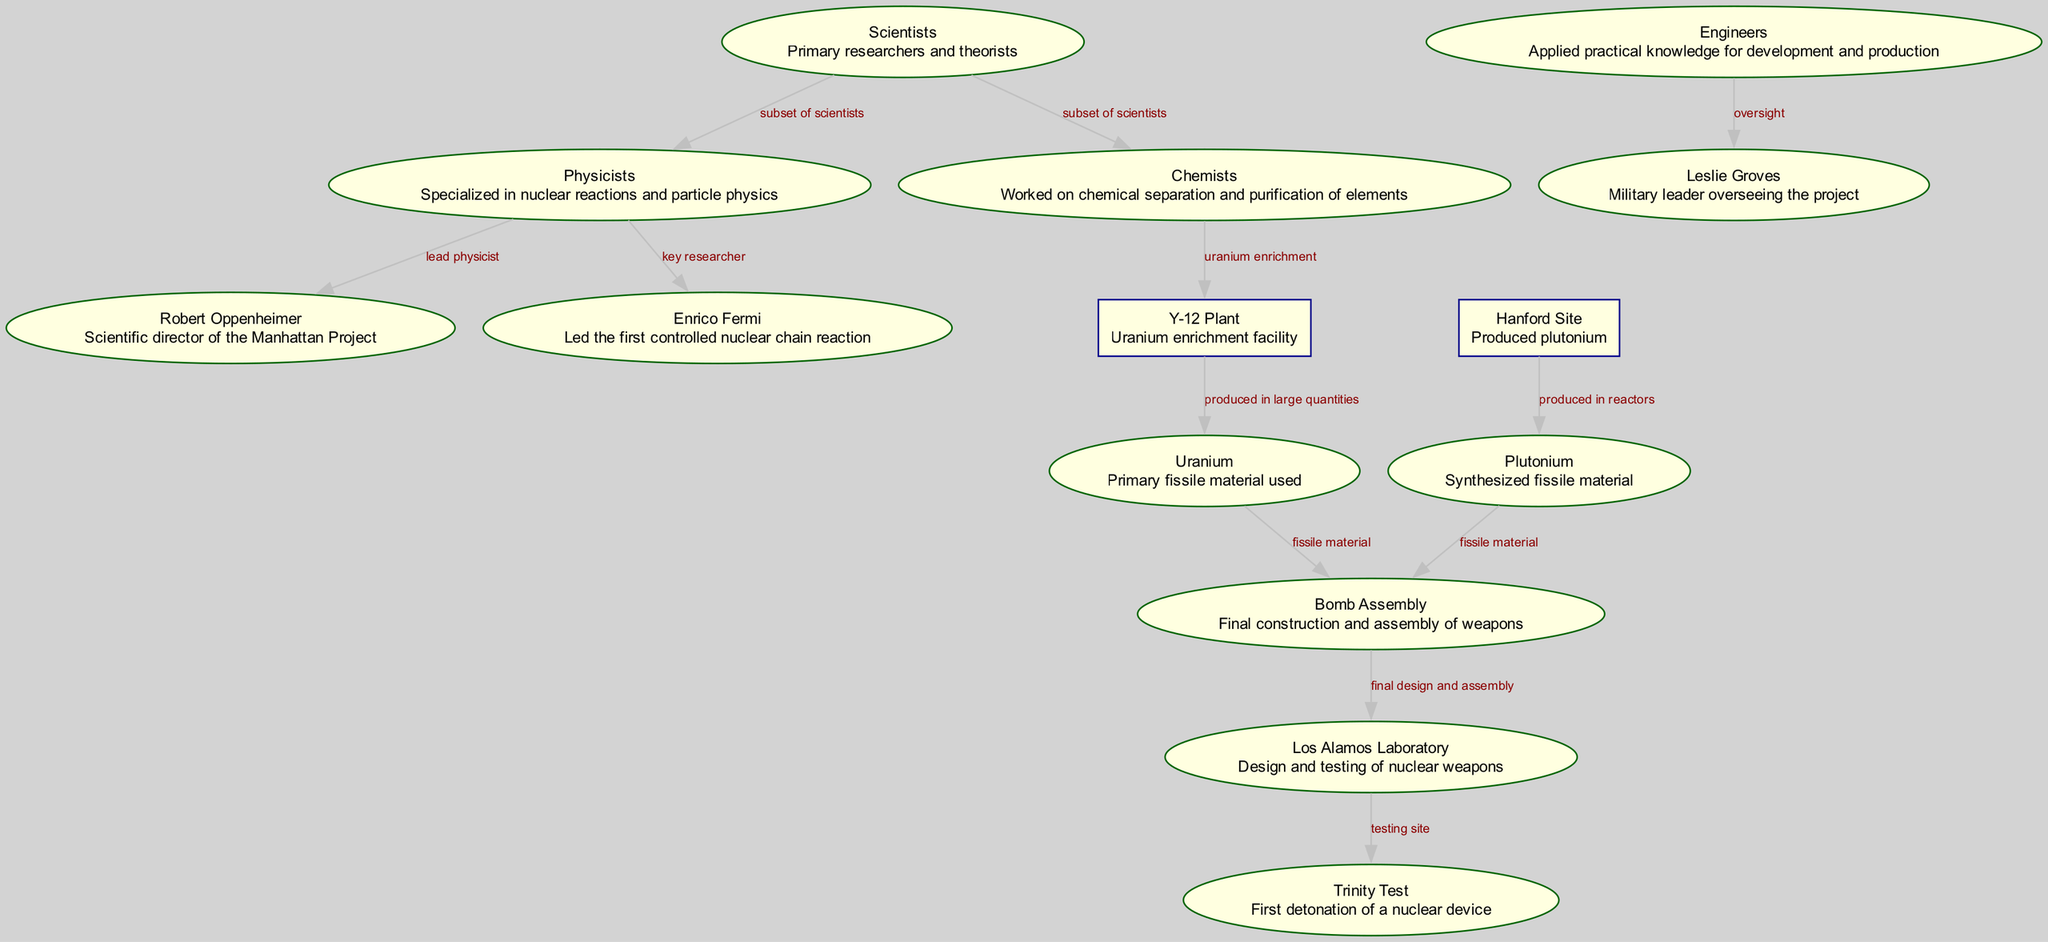What is the role of Robert Oppenheimer? Robert Oppenheimer is labeled as the "Scientific director of the Manhattan Project." This indicates that his main responsibility was to oversee scientific aspects of the project, directing research and development efforts.
Answer: Scientific director How many types of scientists are mentioned? The diagram defines two subsets of scientists: Physicists and Chemists. This clearly indicates that the total number of types of scientists mentioned is two.
Answer: Two Which site produced plutonium? The Hanford Site is specifically described as the "Produced plutonium," signifying that it was responsible for the output of this fissile material during the Manhattan Project.
Answer: Hanford Site Who led the first controlled nuclear chain reaction? Enrico Fermi is noted as the "Led the first controlled nuclear chain reaction," indicating that he played a crucial role in demonstrating this significant scientific breakthrough.
Answer: Enrico Fermi What facility was responsible for uranium enrichment? The Y-12 Plant is indicated to have worked on "uranium enrichment," establishing it as the facility focused on this specific process required for the Manhattan Project.
Answer: Y-12 Plant What was produced in large quantities at the Y-12 Plant? The diagram states that the Y-12 Plant "produced in large quantities" uranium, making it clear that uranium was the primary output of this facility.
Answer: Uranium What is the significance of the Trinity Test? The Trinity Test is noted in the diagram as the "First detonation of a nuclear device." This signifies its importance as the initial demonstration of a nuclear weapon's functionality.
Answer: First detonation What role did Leslie Groves play in the project? Leslie Groves is described as the "Military leader overseeing the project," indicating his significant position and responsibility in managing the overall Manhattan Project activities.
Answer: Military leader Which two materials were used in bomb assembly? The diagram lists both Uranium and Plutonium as materials for bomb assembly, showing their dual role as the primary fissile materials used in the weapon's construction.
Answer: Uranium, Plutonium 